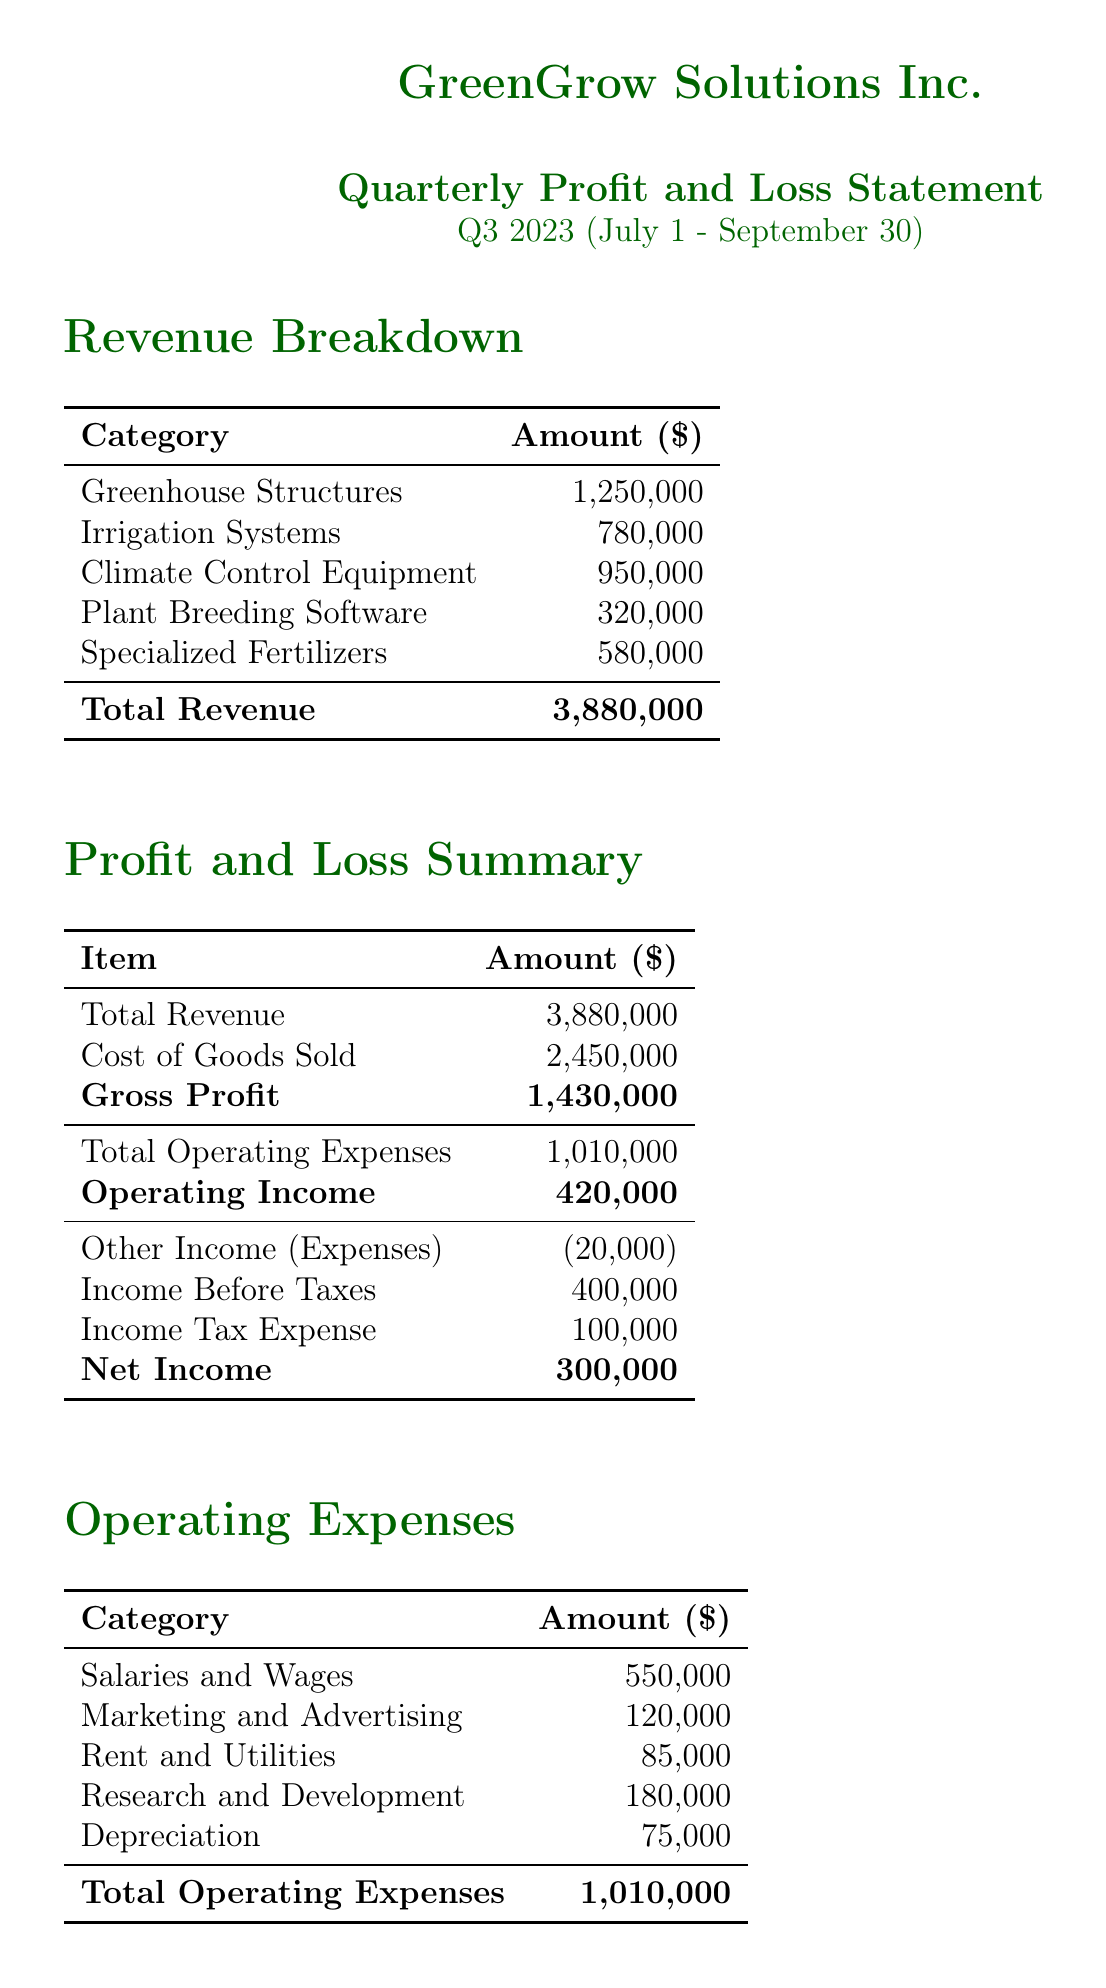what is the total revenue? The total revenue is the sum of all revenue sources listed, which is 1,250,000 + 780,000 + 950,000 + 320,000 + 580,000 = 3,880,000.
Answer: 3,880,000 what is the net income for Q3 2023? The net income is provided directly in the document as the amount remaining after all expenses, which is 300,000.
Answer: 300,000 what is the gross profit margin? The gross profit margin is given in the key performance indicators section as a percentage representing the gross profit relative to total revenue, which is 36.8%.
Answer: 36.8% how much was spent on research and development? The amount spent on research and development is listed in the operating expenses section as 180,000.
Answer: 180,000 what notable event involved a new hydroponic system? The document mentions the launch of a new hydroponic system specifically for tomato breeding as one of the notable events.
Answer: Launched new hydroponic system for tomato breeding what is the total operating expenses? The total operating expenses are detailed in the document and added up to 1,010,000.
Answer: 1,010,000 how many new states was the distribution network expanded to? The document states that the distribution network was expanded to include 3 new states.
Answer: 3 what was the interest expense listed in other income expenses? The interest expense is noted as a negative amount of 35,000 in the document.
Answer: -35,000 what is the operating profit? The operating profit is defined in the profit and loss summary as 420,000.
Answer: 420,000 